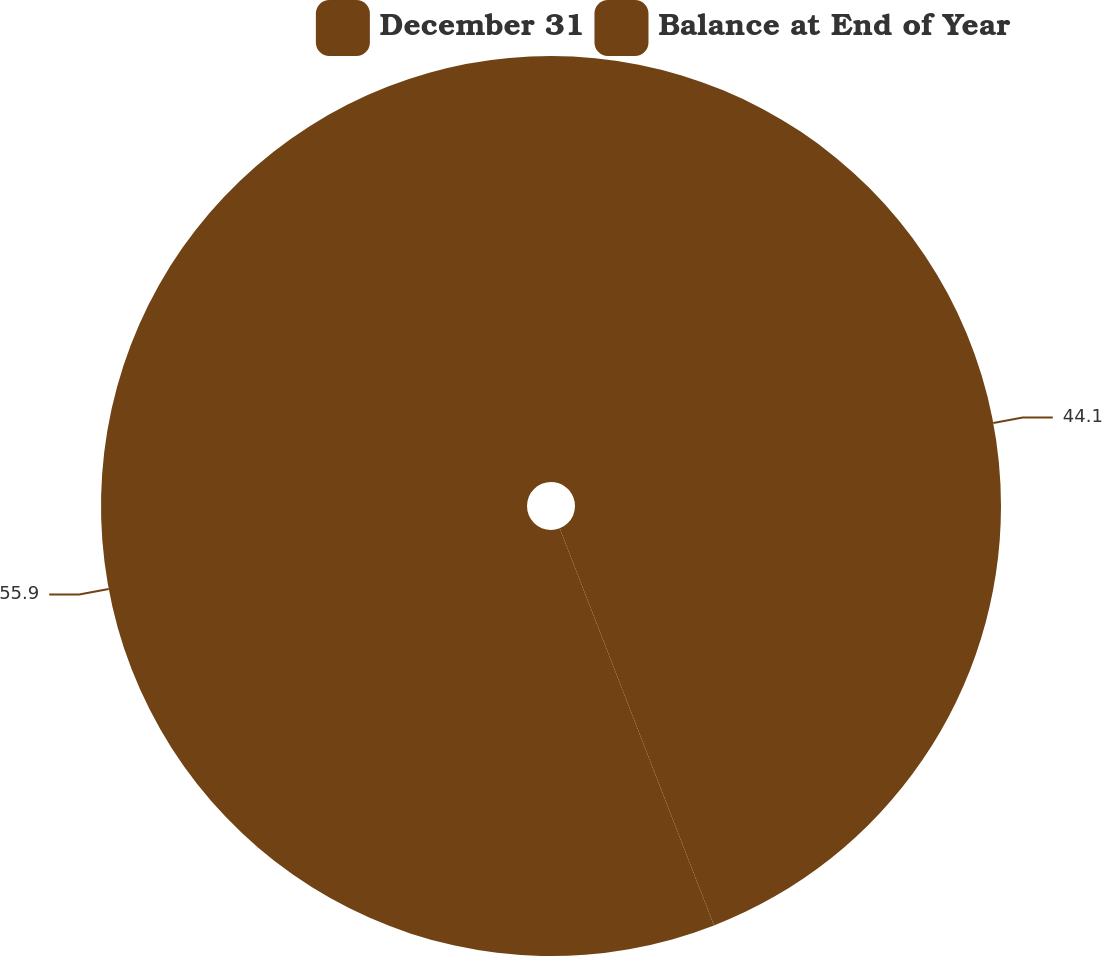Convert chart to OTSL. <chart><loc_0><loc_0><loc_500><loc_500><pie_chart><fcel>December 31<fcel>Balance at End of Year<nl><fcel>44.1%<fcel>55.9%<nl></chart> 